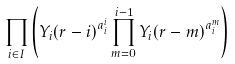Convert formula to latex. <formula><loc_0><loc_0><loc_500><loc_500>\prod _ { i \in I } \left ( { Y _ { i } ( r - i ) } ^ { a _ { i } ^ { i } } \prod _ { m = 0 } ^ { i - 1 } { Y _ { i } ( r - m ) } ^ { a _ { i } ^ { m } } \right )</formula> 